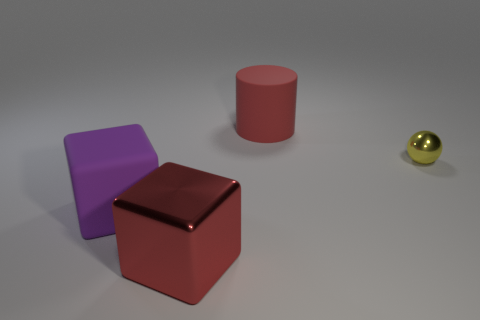Add 4 big matte cubes. How many objects exist? 8 Subtract all cylinders. How many objects are left? 3 Subtract 0 gray spheres. How many objects are left? 4 Subtract all tiny brown rubber spheres. Subtract all metallic balls. How many objects are left? 3 Add 1 large metallic things. How many large metallic things are left? 2 Add 4 red cubes. How many red cubes exist? 5 